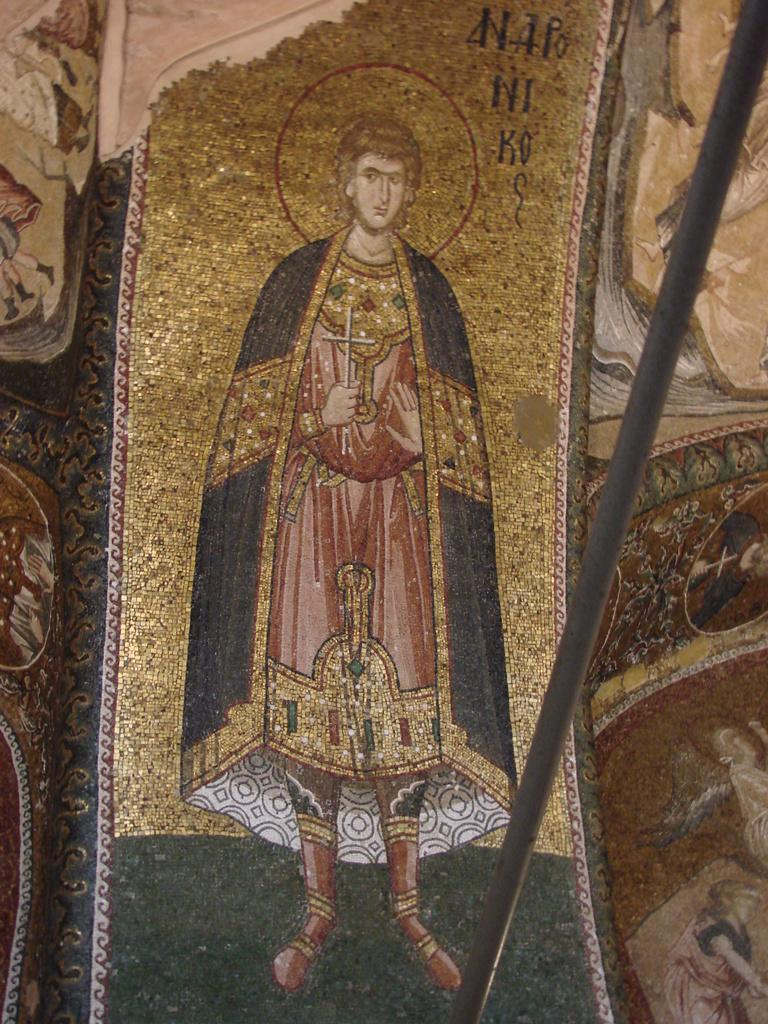What is the main subject of the image? There is a picture of a person in the image. What is the person doing or standing on in the image? The person is on an object. What else can be seen in the image besides the person's picture? There are other objects beside the person's picture. How many sheep are visible in the image? There are no sheep present in the image. What is the person's relationship to the uncle and grandmother in the image? There is no mention of an uncle or grandmother in the image, so their relationship cannot be determined. 